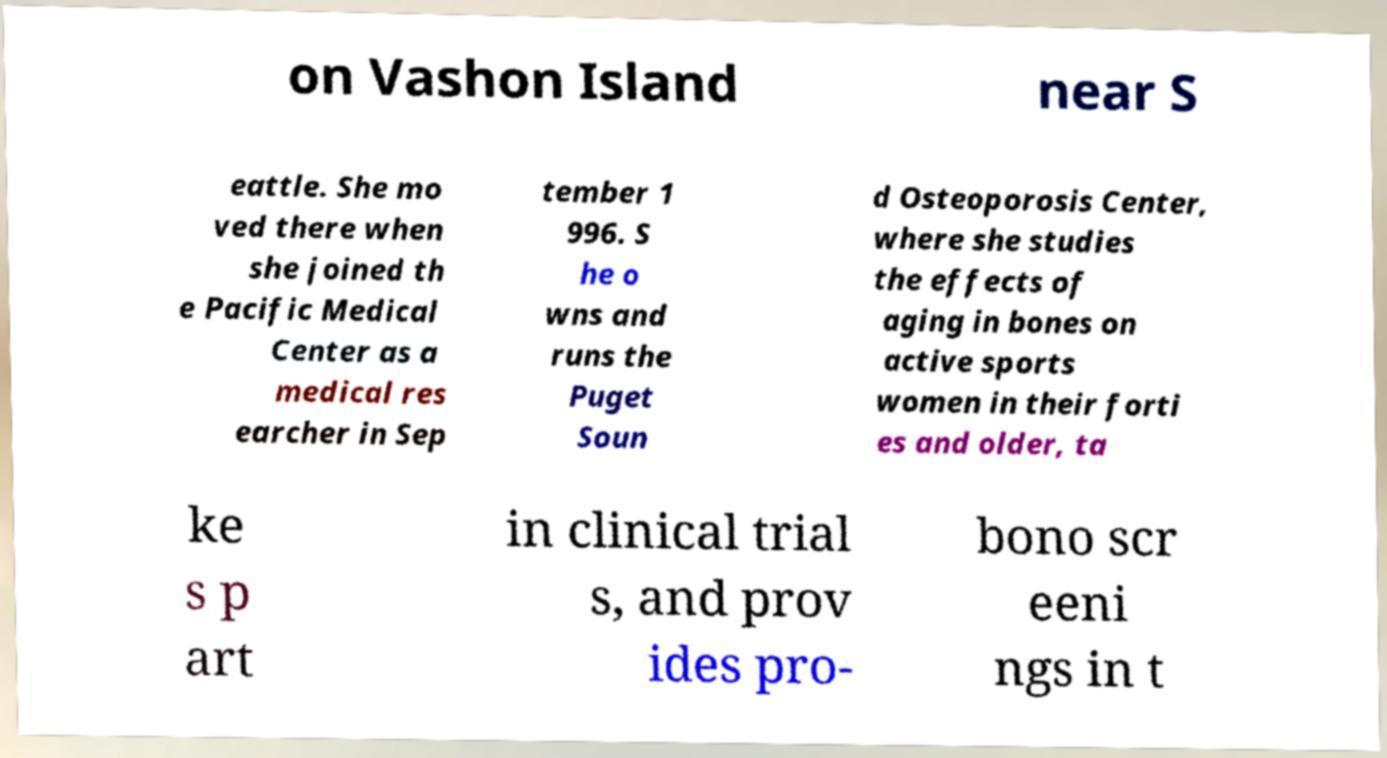I need the written content from this picture converted into text. Can you do that? on Vashon Island near S eattle. She mo ved there when she joined th e Pacific Medical Center as a medical res earcher in Sep tember 1 996. S he o wns and runs the Puget Soun d Osteoporosis Center, where she studies the effects of aging in bones on active sports women in their forti es and older, ta ke s p art in clinical trial s, and prov ides pro- bono scr eeni ngs in t 